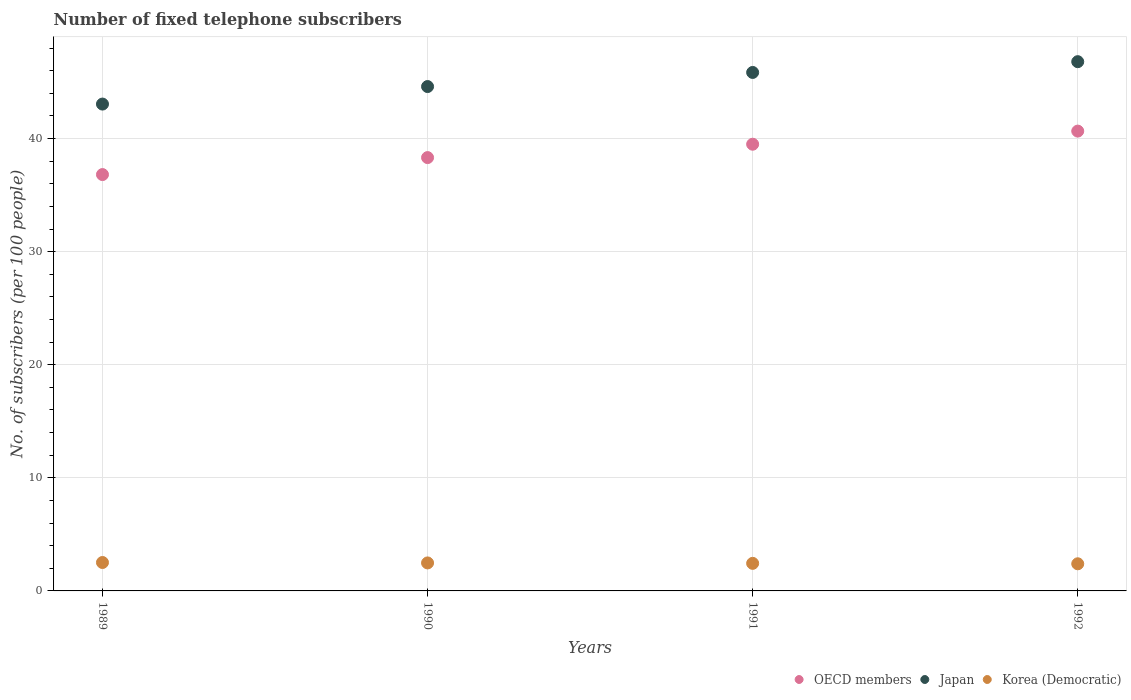How many different coloured dotlines are there?
Ensure brevity in your answer.  3. What is the number of fixed telephone subscribers in Korea (Democratic) in 1990?
Offer a very short reply. 2.48. Across all years, what is the maximum number of fixed telephone subscribers in OECD members?
Your answer should be very brief. 40.66. Across all years, what is the minimum number of fixed telephone subscribers in OECD members?
Provide a succinct answer. 36.82. In which year was the number of fixed telephone subscribers in Korea (Democratic) maximum?
Provide a succinct answer. 1989. In which year was the number of fixed telephone subscribers in Japan minimum?
Your response must be concise. 1989. What is the total number of fixed telephone subscribers in Korea (Democratic) in the graph?
Give a very brief answer. 9.83. What is the difference between the number of fixed telephone subscribers in Japan in 1991 and that in 1992?
Provide a succinct answer. -0.95. What is the difference between the number of fixed telephone subscribers in Japan in 1991 and the number of fixed telephone subscribers in Korea (Democratic) in 1989?
Keep it short and to the point. 43.34. What is the average number of fixed telephone subscribers in Japan per year?
Ensure brevity in your answer.  45.08. In the year 1989, what is the difference between the number of fixed telephone subscribers in OECD members and number of fixed telephone subscribers in Japan?
Your response must be concise. -6.23. In how many years, is the number of fixed telephone subscribers in OECD members greater than 10?
Keep it short and to the point. 4. What is the ratio of the number of fixed telephone subscribers in Japan in 1991 to that in 1992?
Provide a succinct answer. 0.98. Is the number of fixed telephone subscribers in OECD members in 1989 less than that in 1992?
Give a very brief answer. Yes. What is the difference between the highest and the second highest number of fixed telephone subscribers in Korea (Democratic)?
Your answer should be compact. 0.04. What is the difference between the highest and the lowest number of fixed telephone subscribers in Japan?
Offer a terse response. 3.75. Is the sum of the number of fixed telephone subscribers in Japan in 1989 and 1990 greater than the maximum number of fixed telephone subscribers in OECD members across all years?
Provide a short and direct response. Yes. Does the number of fixed telephone subscribers in Korea (Democratic) monotonically increase over the years?
Ensure brevity in your answer.  No. How many dotlines are there?
Provide a short and direct response. 3. What is the difference between two consecutive major ticks on the Y-axis?
Provide a short and direct response. 10. Are the values on the major ticks of Y-axis written in scientific E-notation?
Your answer should be very brief. No. Does the graph contain any zero values?
Provide a short and direct response. No. Does the graph contain grids?
Your answer should be very brief. Yes. Where does the legend appear in the graph?
Your answer should be very brief. Bottom right. How are the legend labels stacked?
Your response must be concise. Horizontal. What is the title of the graph?
Offer a very short reply. Number of fixed telephone subscribers. What is the label or title of the X-axis?
Make the answer very short. Years. What is the label or title of the Y-axis?
Your answer should be compact. No. of subscribers (per 100 people). What is the No. of subscribers (per 100 people) of OECD members in 1989?
Keep it short and to the point. 36.82. What is the No. of subscribers (per 100 people) of Japan in 1989?
Make the answer very short. 43.05. What is the No. of subscribers (per 100 people) of Korea (Democratic) in 1989?
Provide a short and direct response. 2.51. What is the No. of subscribers (per 100 people) in OECD members in 1990?
Provide a succinct answer. 38.32. What is the No. of subscribers (per 100 people) in Japan in 1990?
Give a very brief answer. 44.6. What is the No. of subscribers (per 100 people) of Korea (Democratic) in 1990?
Ensure brevity in your answer.  2.48. What is the No. of subscribers (per 100 people) of OECD members in 1991?
Make the answer very short. 39.5. What is the No. of subscribers (per 100 people) of Japan in 1991?
Your answer should be very brief. 45.85. What is the No. of subscribers (per 100 people) in Korea (Democratic) in 1991?
Keep it short and to the point. 2.44. What is the No. of subscribers (per 100 people) in OECD members in 1992?
Your response must be concise. 40.66. What is the No. of subscribers (per 100 people) in Japan in 1992?
Provide a succinct answer. 46.8. What is the No. of subscribers (per 100 people) in Korea (Democratic) in 1992?
Your response must be concise. 2.4. Across all years, what is the maximum No. of subscribers (per 100 people) of OECD members?
Keep it short and to the point. 40.66. Across all years, what is the maximum No. of subscribers (per 100 people) of Japan?
Provide a succinct answer. 46.8. Across all years, what is the maximum No. of subscribers (per 100 people) in Korea (Democratic)?
Provide a short and direct response. 2.51. Across all years, what is the minimum No. of subscribers (per 100 people) in OECD members?
Offer a terse response. 36.82. Across all years, what is the minimum No. of subscribers (per 100 people) of Japan?
Keep it short and to the point. 43.05. Across all years, what is the minimum No. of subscribers (per 100 people) of Korea (Democratic)?
Provide a short and direct response. 2.4. What is the total No. of subscribers (per 100 people) of OECD members in the graph?
Your response must be concise. 155.31. What is the total No. of subscribers (per 100 people) in Japan in the graph?
Give a very brief answer. 180.31. What is the total No. of subscribers (per 100 people) of Korea (Democratic) in the graph?
Your response must be concise. 9.83. What is the difference between the No. of subscribers (per 100 people) of OECD members in 1989 and that in 1990?
Your response must be concise. -1.5. What is the difference between the No. of subscribers (per 100 people) in Japan in 1989 and that in 1990?
Offer a terse response. -1.55. What is the difference between the No. of subscribers (per 100 people) of Korea (Democratic) in 1989 and that in 1990?
Offer a very short reply. 0.04. What is the difference between the No. of subscribers (per 100 people) in OECD members in 1989 and that in 1991?
Make the answer very short. -2.68. What is the difference between the No. of subscribers (per 100 people) in Japan in 1989 and that in 1991?
Provide a short and direct response. -2.8. What is the difference between the No. of subscribers (per 100 people) of Korea (Democratic) in 1989 and that in 1991?
Give a very brief answer. 0.08. What is the difference between the No. of subscribers (per 100 people) in OECD members in 1989 and that in 1992?
Provide a short and direct response. -3.84. What is the difference between the No. of subscribers (per 100 people) in Japan in 1989 and that in 1992?
Offer a very short reply. -3.75. What is the difference between the No. of subscribers (per 100 people) of Korea (Democratic) in 1989 and that in 1992?
Your answer should be very brief. 0.11. What is the difference between the No. of subscribers (per 100 people) in OECD members in 1990 and that in 1991?
Offer a very short reply. -1.18. What is the difference between the No. of subscribers (per 100 people) of Japan in 1990 and that in 1991?
Provide a short and direct response. -1.25. What is the difference between the No. of subscribers (per 100 people) of Korea (Democratic) in 1990 and that in 1991?
Provide a short and direct response. 0.04. What is the difference between the No. of subscribers (per 100 people) in OECD members in 1990 and that in 1992?
Keep it short and to the point. -2.34. What is the difference between the No. of subscribers (per 100 people) of Japan in 1990 and that in 1992?
Your response must be concise. -2.2. What is the difference between the No. of subscribers (per 100 people) of Korea (Democratic) in 1990 and that in 1992?
Offer a terse response. 0.08. What is the difference between the No. of subscribers (per 100 people) of OECD members in 1991 and that in 1992?
Provide a succinct answer. -1.16. What is the difference between the No. of subscribers (per 100 people) of Japan in 1991 and that in 1992?
Give a very brief answer. -0.95. What is the difference between the No. of subscribers (per 100 people) of Korea (Democratic) in 1991 and that in 1992?
Ensure brevity in your answer.  0.04. What is the difference between the No. of subscribers (per 100 people) of OECD members in 1989 and the No. of subscribers (per 100 people) of Japan in 1990?
Keep it short and to the point. -7.78. What is the difference between the No. of subscribers (per 100 people) in OECD members in 1989 and the No. of subscribers (per 100 people) in Korea (Democratic) in 1990?
Your answer should be very brief. 34.34. What is the difference between the No. of subscribers (per 100 people) in Japan in 1989 and the No. of subscribers (per 100 people) in Korea (Democratic) in 1990?
Give a very brief answer. 40.58. What is the difference between the No. of subscribers (per 100 people) in OECD members in 1989 and the No. of subscribers (per 100 people) in Japan in 1991?
Provide a succinct answer. -9.03. What is the difference between the No. of subscribers (per 100 people) of OECD members in 1989 and the No. of subscribers (per 100 people) of Korea (Democratic) in 1991?
Keep it short and to the point. 34.38. What is the difference between the No. of subscribers (per 100 people) of Japan in 1989 and the No. of subscribers (per 100 people) of Korea (Democratic) in 1991?
Give a very brief answer. 40.62. What is the difference between the No. of subscribers (per 100 people) of OECD members in 1989 and the No. of subscribers (per 100 people) of Japan in 1992?
Your answer should be compact. -9.98. What is the difference between the No. of subscribers (per 100 people) in OECD members in 1989 and the No. of subscribers (per 100 people) in Korea (Democratic) in 1992?
Your answer should be very brief. 34.42. What is the difference between the No. of subscribers (per 100 people) of Japan in 1989 and the No. of subscribers (per 100 people) of Korea (Democratic) in 1992?
Keep it short and to the point. 40.65. What is the difference between the No. of subscribers (per 100 people) of OECD members in 1990 and the No. of subscribers (per 100 people) of Japan in 1991?
Your answer should be compact. -7.53. What is the difference between the No. of subscribers (per 100 people) of OECD members in 1990 and the No. of subscribers (per 100 people) of Korea (Democratic) in 1991?
Give a very brief answer. 35.88. What is the difference between the No. of subscribers (per 100 people) in Japan in 1990 and the No. of subscribers (per 100 people) in Korea (Democratic) in 1991?
Offer a terse response. 42.17. What is the difference between the No. of subscribers (per 100 people) of OECD members in 1990 and the No. of subscribers (per 100 people) of Japan in 1992?
Make the answer very short. -8.48. What is the difference between the No. of subscribers (per 100 people) in OECD members in 1990 and the No. of subscribers (per 100 people) in Korea (Democratic) in 1992?
Your response must be concise. 35.92. What is the difference between the No. of subscribers (per 100 people) of Japan in 1990 and the No. of subscribers (per 100 people) of Korea (Democratic) in 1992?
Offer a very short reply. 42.2. What is the difference between the No. of subscribers (per 100 people) in OECD members in 1991 and the No. of subscribers (per 100 people) in Japan in 1992?
Offer a terse response. -7.3. What is the difference between the No. of subscribers (per 100 people) of OECD members in 1991 and the No. of subscribers (per 100 people) of Korea (Democratic) in 1992?
Keep it short and to the point. 37.1. What is the difference between the No. of subscribers (per 100 people) in Japan in 1991 and the No. of subscribers (per 100 people) in Korea (Democratic) in 1992?
Your response must be concise. 43.45. What is the average No. of subscribers (per 100 people) of OECD members per year?
Your answer should be compact. 38.83. What is the average No. of subscribers (per 100 people) in Japan per year?
Your answer should be very brief. 45.08. What is the average No. of subscribers (per 100 people) in Korea (Democratic) per year?
Offer a very short reply. 2.46. In the year 1989, what is the difference between the No. of subscribers (per 100 people) of OECD members and No. of subscribers (per 100 people) of Japan?
Your answer should be compact. -6.23. In the year 1989, what is the difference between the No. of subscribers (per 100 people) of OECD members and No. of subscribers (per 100 people) of Korea (Democratic)?
Your response must be concise. 34.31. In the year 1989, what is the difference between the No. of subscribers (per 100 people) in Japan and No. of subscribers (per 100 people) in Korea (Democratic)?
Ensure brevity in your answer.  40.54. In the year 1990, what is the difference between the No. of subscribers (per 100 people) of OECD members and No. of subscribers (per 100 people) of Japan?
Keep it short and to the point. -6.28. In the year 1990, what is the difference between the No. of subscribers (per 100 people) in OECD members and No. of subscribers (per 100 people) in Korea (Democratic)?
Make the answer very short. 35.85. In the year 1990, what is the difference between the No. of subscribers (per 100 people) of Japan and No. of subscribers (per 100 people) of Korea (Democratic)?
Ensure brevity in your answer.  42.13. In the year 1991, what is the difference between the No. of subscribers (per 100 people) in OECD members and No. of subscribers (per 100 people) in Japan?
Offer a terse response. -6.35. In the year 1991, what is the difference between the No. of subscribers (per 100 people) of OECD members and No. of subscribers (per 100 people) of Korea (Democratic)?
Your answer should be very brief. 37.07. In the year 1991, what is the difference between the No. of subscribers (per 100 people) of Japan and No. of subscribers (per 100 people) of Korea (Democratic)?
Give a very brief answer. 43.41. In the year 1992, what is the difference between the No. of subscribers (per 100 people) in OECD members and No. of subscribers (per 100 people) in Japan?
Make the answer very short. -6.14. In the year 1992, what is the difference between the No. of subscribers (per 100 people) in OECD members and No. of subscribers (per 100 people) in Korea (Democratic)?
Make the answer very short. 38.26. In the year 1992, what is the difference between the No. of subscribers (per 100 people) in Japan and No. of subscribers (per 100 people) in Korea (Democratic)?
Offer a terse response. 44.4. What is the ratio of the No. of subscribers (per 100 people) in OECD members in 1989 to that in 1990?
Give a very brief answer. 0.96. What is the ratio of the No. of subscribers (per 100 people) in Japan in 1989 to that in 1990?
Your answer should be very brief. 0.97. What is the ratio of the No. of subscribers (per 100 people) of Korea (Democratic) in 1989 to that in 1990?
Provide a succinct answer. 1.01. What is the ratio of the No. of subscribers (per 100 people) in OECD members in 1989 to that in 1991?
Ensure brevity in your answer.  0.93. What is the ratio of the No. of subscribers (per 100 people) in Japan in 1989 to that in 1991?
Ensure brevity in your answer.  0.94. What is the ratio of the No. of subscribers (per 100 people) of Korea (Democratic) in 1989 to that in 1991?
Your answer should be compact. 1.03. What is the ratio of the No. of subscribers (per 100 people) of OECD members in 1989 to that in 1992?
Provide a short and direct response. 0.91. What is the ratio of the No. of subscribers (per 100 people) of Japan in 1989 to that in 1992?
Keep it short and to the point. 0.92. What is the ratio of the No. of subscribers (per 100 people) in Korea (Democratic) in 1989 to that in 1992?
Offer a very short reply. 1.05. What is the ratio of the No. of subscribers (per 100 people) in OECD members in 1990 to that in 1991?
Offer a terse response. 0.97. What is the ratio of the No. of subscribers (per 100 people) of Japan in 1990 to that in 1991?
Give a very brief answer. 0.97. What is the ratio of the No. of subscribers (per 100 people) in Korea (Democratic) in 1990 to that in 1991?
Offer a terse response. 1.02. What is the ratio of the No. of subscribers (per 100 people) in OECD members in 1990 to that in 1992?
Provide a short and direct response. 0.94. What is the ratio of the No. of subscribers (per 100 people) of Japan in 1990 to that in 1992?
Give a very brief answer. 0.95. What is the ratio of the No. of subscribers (per 100 people) of Korea (Democratic) in 1990 to that in 1992?
Offer a terse response. 1.03. What is the ratio of the No. of subscribers (per 100 people) in OECD members in 1991 to that in 1992?
Provide a short and direct response. 0.97. What is the ratio of the No. of subscribers (per 100 people) in Japan in 1991 to that in 1992?
Give a very brief answer. 0.98. What is the ratio of the No. of subscribers (per 100 people) in Korea (Democratic) in 1991 to that in 1992?
Your answer should be compact. 1.02. What is the difference between the highest and the second highest No. of subscribers (per 100 people) of OECD members?
Your answer should be very brief. 1.16. What is the difference between the highest and the second highest No. of subscribers (per 100 people) in Japan?
Keep it short and to the point. 0.95. What is the difference between the highest and the second highest No. of subscribers (per 100 people) in Korea (Democratic)?
Your response must be concise. 0.04. What is the difference between the highest and the lowest No. of subscribers (per 100 people) of OECD members?
Offer a very short reply. 3.84. What is the difference between the highest and the lowest No. of subscribers (per 100 people) of Japan?
Ensure brevity in your answer.  3.75. What is the difference between the highest and the lowest No. of subscribers (per 100 people) in Korea (Democratic)?
Your answer should be very brief. 0.11. 